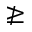<formula> <loc_0><loc_0><loc_500><loc_500>\ngeq</formula> 